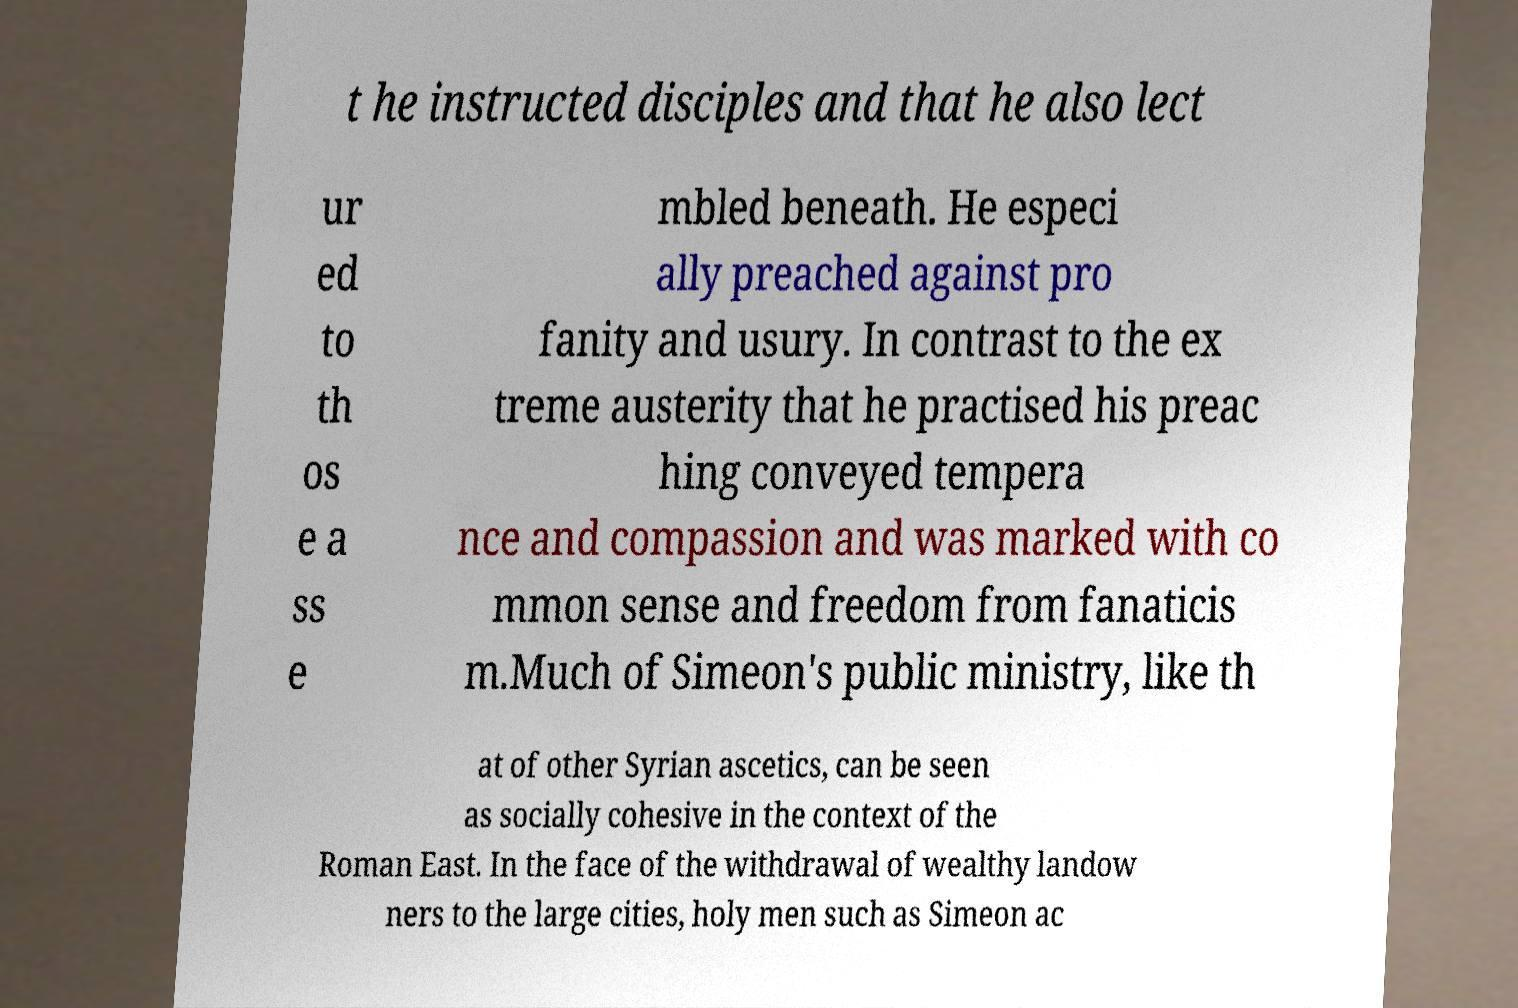What messages or text are displayed in this image? I need them in a readable, typed format. t he instructed disciples and that he also lect ur ed to th os e a ss e mbled beneath. He especi ally preached against pro fanity and usury. In contrast to the ex treme austerity that he practised his preac hing conveyed tempera nce and compassion and was marked with co mmon sense and freedom from fanaticis m.Much of Simeon's public ministry, like th at of other Syrian ascetics, can be seen as socially cohesive in the context of the Roman East. In the face of the withdrawal of wealthy landow ners to the large cities, holy men such as Simeon ac 